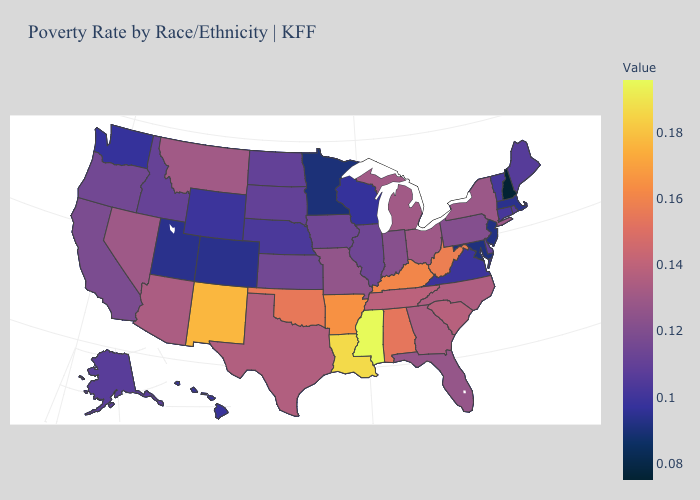Which states have the lowest value in the USA?
Give a very brief answer. New Hampshire. Among the states that border Kansas , does Oklahoma have the highest value?
Keep it brief. Yes. Among the states that border New Jersey , which have the highest value?
Write a very short answer. New York. Is the legend a continuous bar?
Quick response, please. Yes. Does Arizona have a higher value than New Jersey?
Write a very short answer. Yes. Does Pennsylvania have the lowest value in the USA?
Short answer required. No. Among the states that border Wisconsin , which have the highest value?
Answer briefly. Michigan. Does Arkansas have the lowest value in the South?
Write a very short answer. No. 